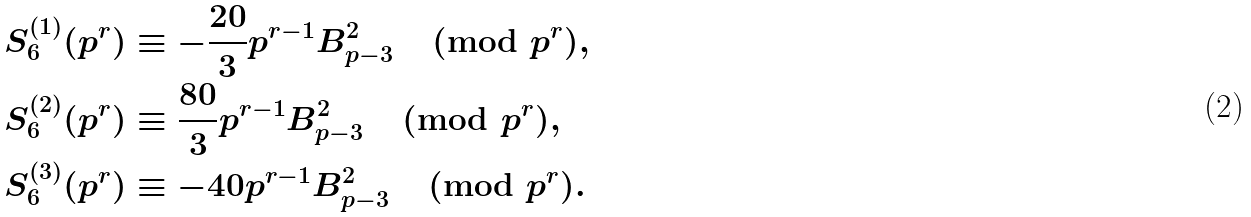<formula> <loc_0><loc_0><loc_500><loc_500>S _ { 6 } ^ { ( 1 ) } ( { { p } ^ { r } } ) & \equiv - \frac { 2 0 } { 3 } p ^ { r - 1 } B _ { p - 3 } ^ { 2 } \pmod { p ^ { r } } , \\ S _ { 6 } ^ { ( 2 ) } ( { { p } ^ { r } } ) & \equiv \frac { 8 0 } { 3 } p ^ { r - 1 } B _ { p - 3 } ^ { 2 } \pmod { p ^ { r } } , \\ S _ { 6 } ^ { ( 3 ) } ( { { p } ^ { r } } ) & \equiv - 4 0 p ^ { r - 1 } B _ { p - 3 } ^ { 2 } \pmod { p ^ { r } } .</formula> 